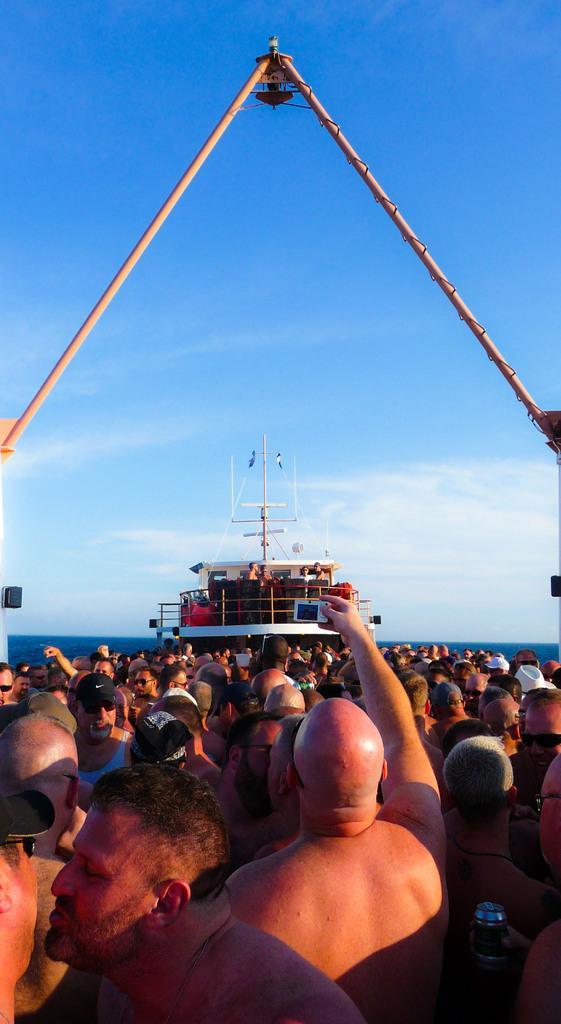How would you summarize this image in a sentence or two? In this image, we can see a group of people. In the middle of the image, we can see a person standing and holding the camera in his hand. In the background, we can see a boat. In the boat, we can see a group of people. On the right side and left side, we can see the pole. At the top, we can see a sky. 